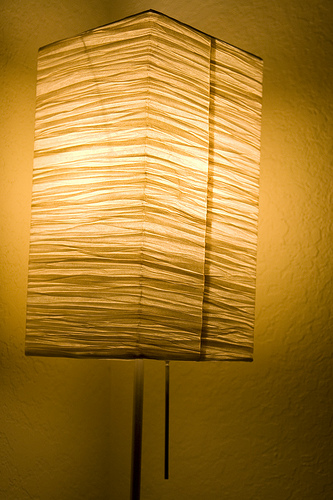<image>
Is there a lamp behind the wall? No. The lamp is not behind the wall. From this viewpoint, the lamp appears to be positioned elsewhere in the scene. 